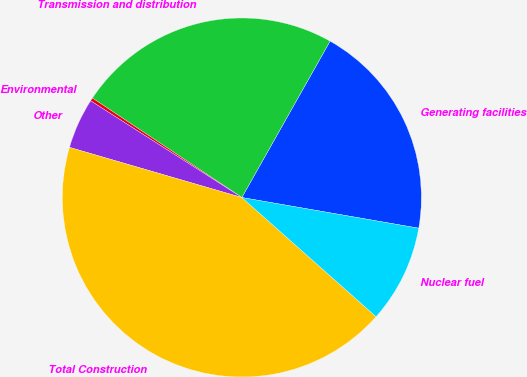Convert chart to OTSL. <chart><loc_0><loc_0><loc_500><loc_500><pie_chart><fcel>Generating facilities<fcel>Transmission and distribution<fcel>Environmental<fcel>Other<fcel>Total Construction<fcel>Nuclear fuel<nl><fcel>19.56%<fcel>23.83%<fcel>0.29%<fcel>4.55%<fcel>42.95%<fcel>8.82%<nl></chart> 